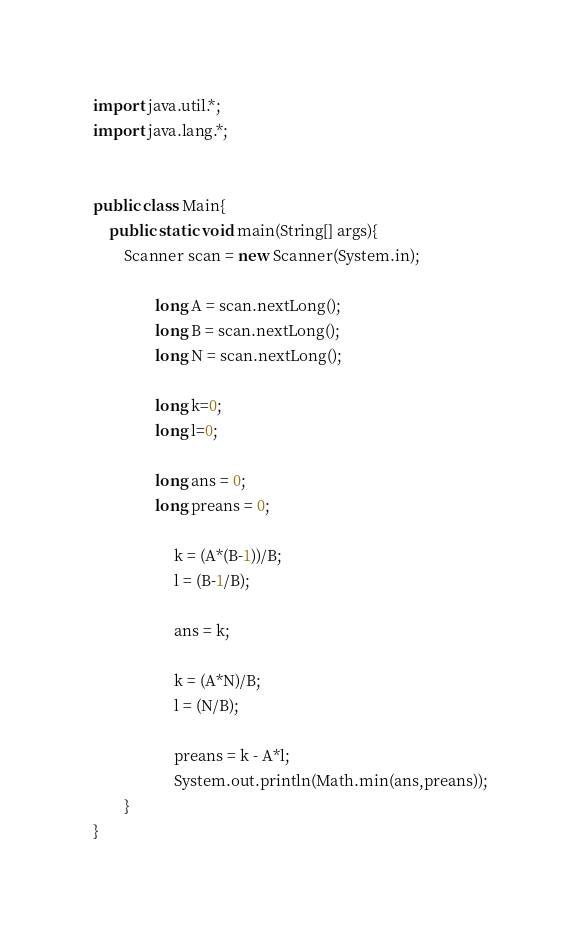Convert code to text. <code><loc_0><loc_0><loc_500><loc_500><_Java_>import java.util.*; 
import java.lang.*; 


public class Main{
	public static void main(String[] args){
		Scanner scan = new Scanner(System.in);
                
                long A = scan.nextLong();
                long B = scan.nextLong();
                long N = scan.nextLong();
                
                long k=0;
                long l=0;
                
                long ans = 0;
                long preans = 0;

                     k = (A*(B-1))/B;
                     l = (B-1/B);

                     ans = k;
                     
                     k = (A*N)/B;
                     l = (N/B);
                     
                     preans = k - A*l;
                     System.out.println(Math.min(ans,preans));
        }
}</code> 